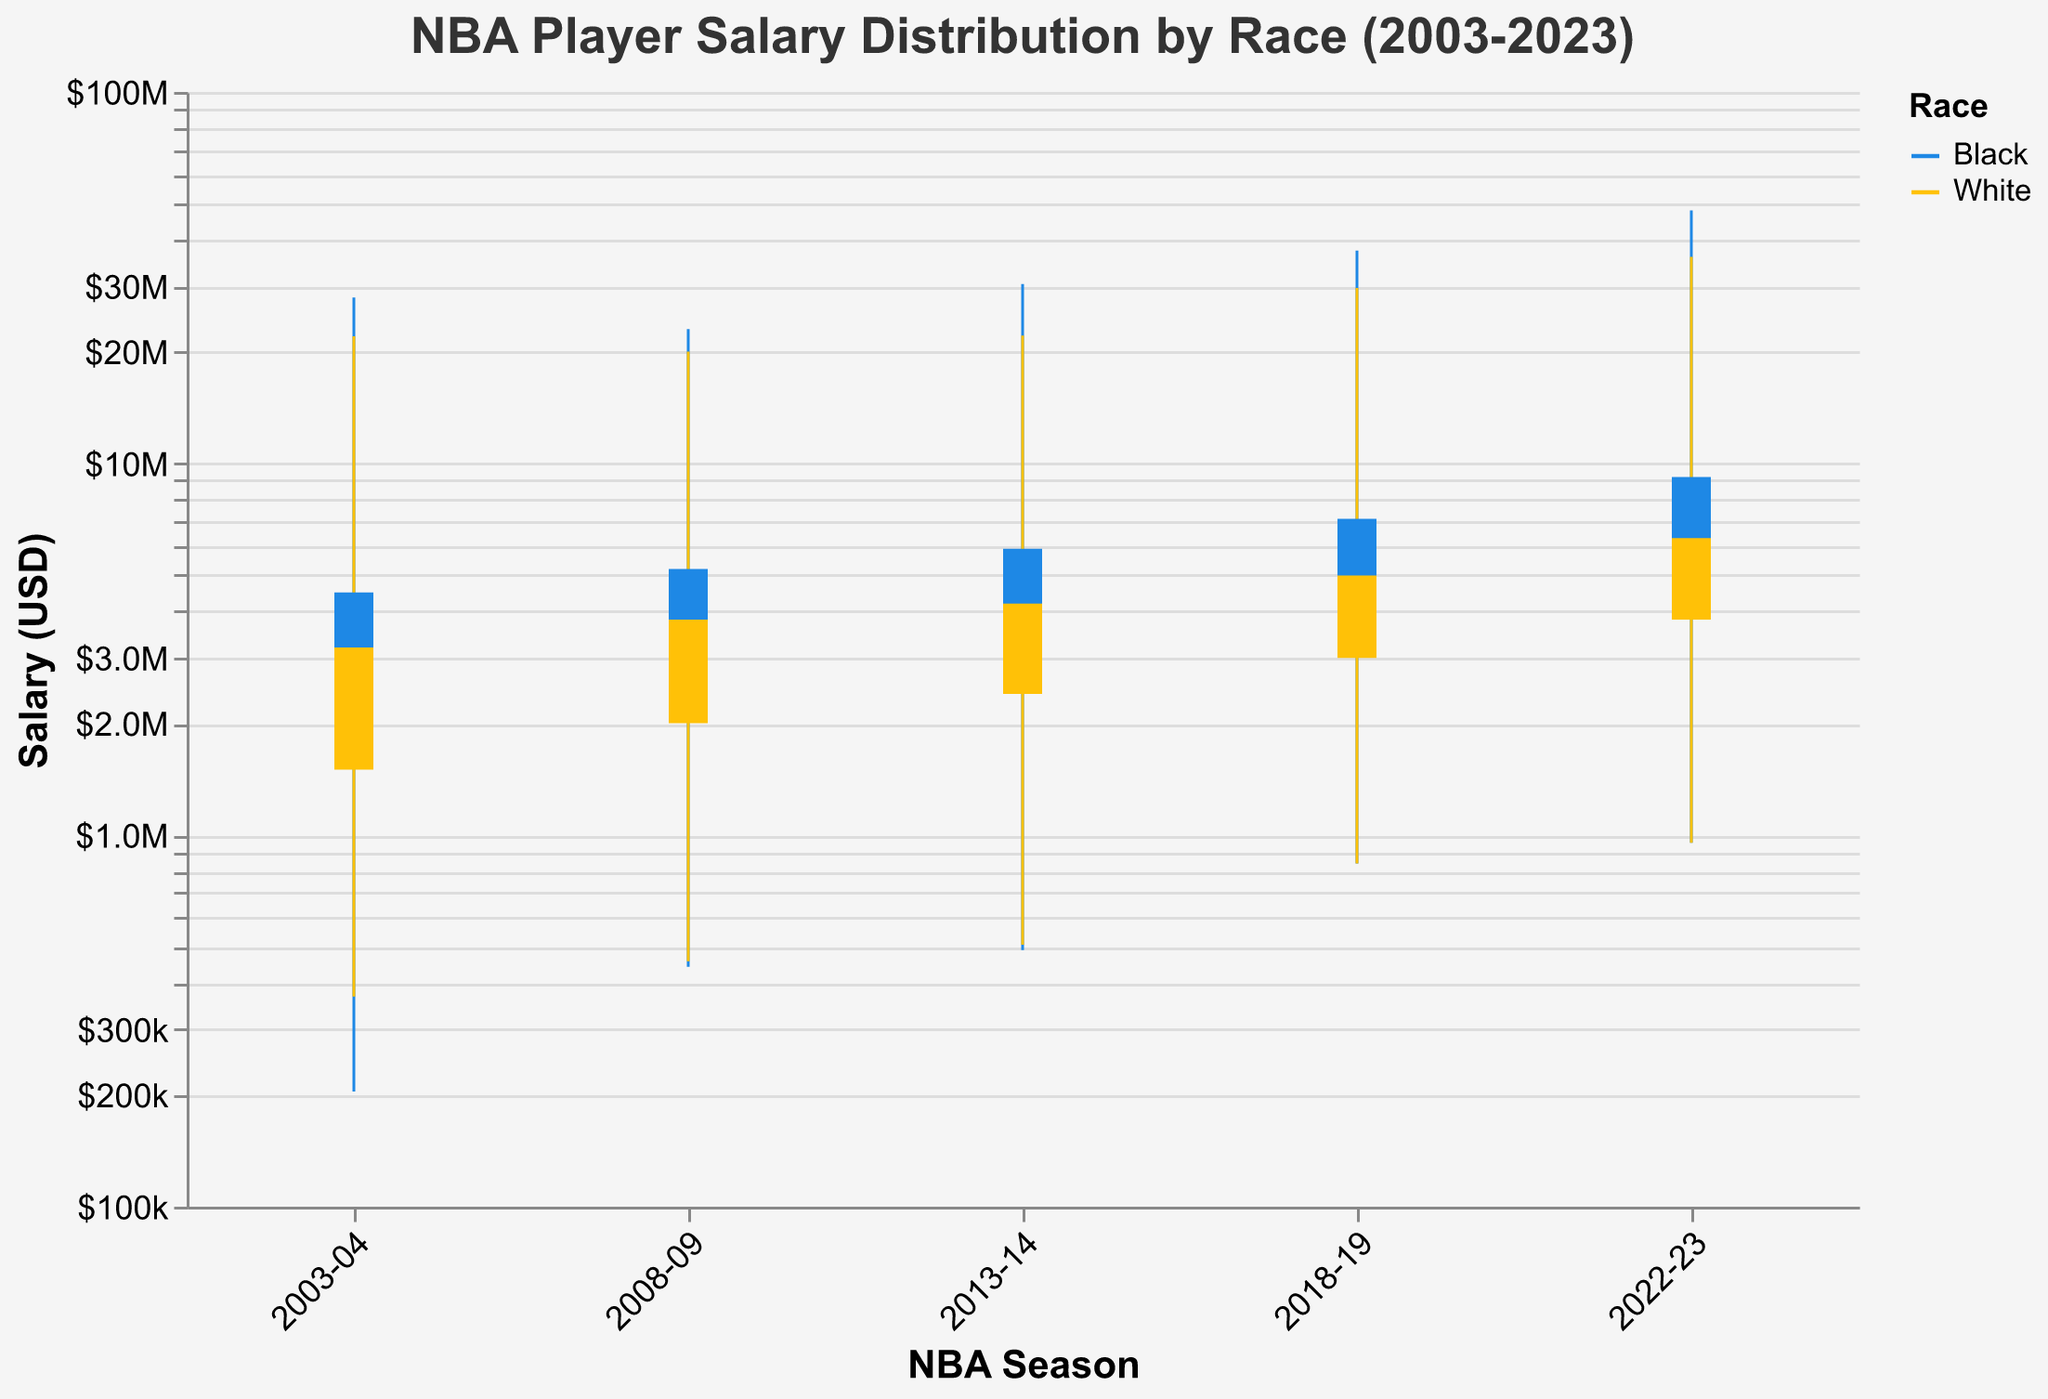How many seasons are represented in the chart? The chart displays the salary distribution over different seasons. By counting the distinct labels on the x-axis of the chart, we can determine the number of seasons.
Answer: 5 What is the highest salary recorded for Black players in the 2022-23 season? Looking at the data for the 2022-23 season for Black players, the highest salary is indicated by the “High” value.
Answer: $48,000,000 How does the closing salary for White players in the 2022-23 season compare to Black players? The closing salary for White players in the 2022-23 season is represented by the “Close” value for 2022-23 and the race “White”. Similarly, the closing salary for Black players is represented by the “Close” value for 2022-23 and the race “Black”. Comparing these values, we have $6,300,000 for White players and $9,200,000 for Black players.
Answer: $9,200,000 > $6,300,000 What was the minimum salary for both races in the 2008-09 season? The minimum salary (or “Low” value) for each race in 2008-09 can be identified. For Black players, it’s $442,114, and for White players, it’s $457,588.
Answer: Black: $442,114, White: $457,588 By how much did the high salaries for Black players increase from the 2003-04 season to the 2022-23 season? The high salary for Black players in the 2003-04 season is $28,000,000. In the 2022-23 season, it is $48,000,000. The increase is calculated by subtracting the 2003-04 value from the 2022-23 value. $48,000,000 - $28,000,000 = $20,000,000.
Answer: $20,000,000 What is the average closing salary for White players across the five seasons? The closing salaries for White players across the five seasons are $3,200,000, $3,800,000, $4,200,000, $5,000,000, and $6,300,000. The average is calculated by summing these values and dividing by the number of seasons. ($3,200,000 + $3,800,000 + $4,200,000 + $5,000,000 + $6,300,000) / 5.
Answer: $4,500,000 Describe the overall trend in the opening salary for Black players from 2003-04 to 2022-23. By observing the opening salary for Black players over the seasons (2003-04: $2,700,000, 2008-09: $3,100,000, 2013-14: $3,800,000, 2018-19: $4,500,000, 2022-23: $5,500,000), we can see an increasing trend.
Answer: Increasing trend What is the difference between the highest salaries for White and Black players in the 2013-14 season? The highest salary (or “High” value) for White players in the 2013-14 season is $22,100,000. For Black players, it is $30,400,000. The difference is calculated by subtracting the higher salary for White players from that for Black players. $30,400,000 - $22,100,000 = $8,300,000.
Answer: $8,300,000 Based on the chart, which race had higher variability in their closing salaries over the 20 seasons? Variability can be judged based on the spread of the closing salaries over the seasons. For White players, the closing salaries range from $3,200,000 to $6,300,000. For Black players, they range from $4,500,000 to $9,200,000. Black players have a higher range, indicating higher variability.
Answer: Black players How much lower was the opening salary for White players compared to Black players in the 2018-19 season? The opening salary in 2018-19 for White players was $3,000,000, whereas for Black players, it was $4,500,000. The difference is calculated by subtracting the opening salary of the White players from that of the Black players. $4,500,000 - $3,000,000 = $1,500,000.
Answer: $1,500,000 